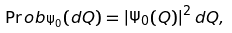<formula> <loc_0><loc_0><loc_500><loc_500>\Pr o b _ { \Psi _ { 0 } } ( d Q ) = { | \Psi _ { 0 } ( Q ) | } ^ { 2 } \, d Q ,</formula> 